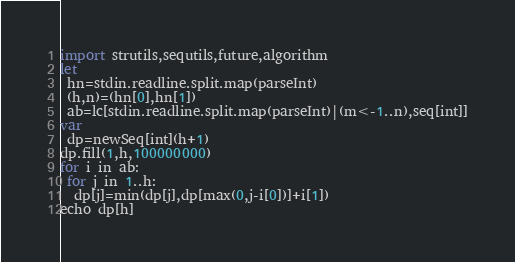<code> <loc_0><loc_0><loc_500><loc_500><_Nim_>import strutils,sequtils,future,algorithm
let
 hn=stdin.readline.split.map(parseInt)
 (h,n)=(hn[0],hn[1])
 ab=lc[stdin.readline.split.map(parseInt)|(m<-1..n),seq[int]]
var
 dp=newSeq[int](h+1)
dp.fill(1,h,100000000)
for i in ab:
 for j in 1..h:
  dp[j]=min(dp[j],dp[max(0,j-i[0])]+i[1])
echo dp[h]</code> 